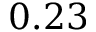<formula> <loc_0><loc_0><loc_500><loc_500>0 . 2 3</formula> 